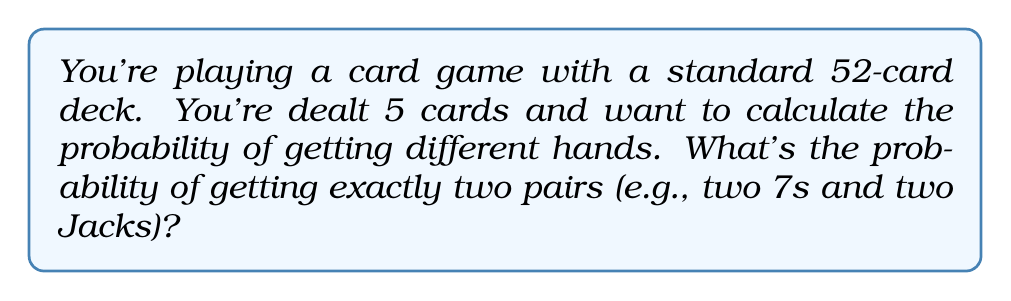Can you answer this question? Let's break this down step-by-step:

1) First, we need to choose the ranks for our two pairs. There are $\binom{13}{2} = 78$ ways to do this.

2) For each pair, we need to choose 2 cards out of 4. This can be done in $\binom{4}{2} = 6$ ways for each pair.

3) For the fifth card, we need to choose 1 card from the remaining 44 cards (52 - 8 cards used in the pairs).

4) The total number of ways to get exactly two pairs is:

   $$78 \times 6 \times 6 \times 44 = 123,552$$

5) The total number of ways to be dealt 5 cards from a 52-card deck is:

   $$\binom{52}{5} = 2,598,960$$

6) Therefore, the probability is:

   $$P(\text{two pairs}) = \frac{123,552}{2,598,960} = \frac{2,058}{43,316} \approx 0.0475$$

This calculation gives us the exact probability as a fraction and an approximate decimal value.
Answer: The probability of getting exactly two pairs in a 5-card hand is $\frac{2,058}{43,316}$ or approximately 0.0475 (4.75%). 